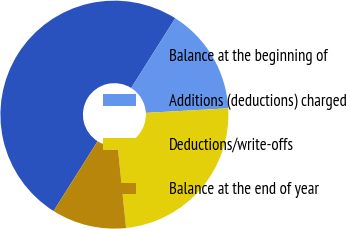Convert chart. <chart><loc_0><loc_0><loc_500><loc_500><pie_chart><fcel>Balance at the beginning of<fcel>Additions (deductions) charged<fcel>Deductions/write-offs<fcel>Balance at the end of year<nl><fcel>50.0%<fcel>15.16%<fcel>24.25%<fcel>10.59%<nl></chart> 